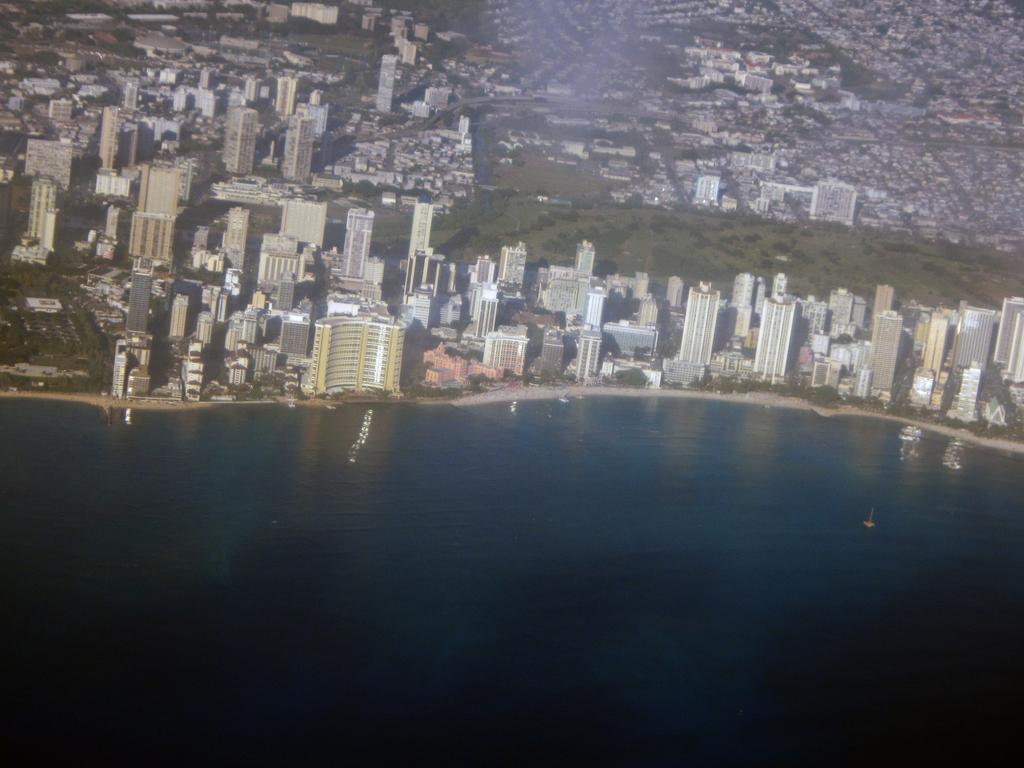What type of structures can be seen in the image? There are buildings in the image. What natural element is visible in the image? There is water visible in the image. What type of vegetation is present in the image? There are trees in the image. What pets are visible in the image? There are no pets visible in the image. What idea is being conveyed through the caption in the image? There is no caption present in the image, so no idea can be conveyed through it. 